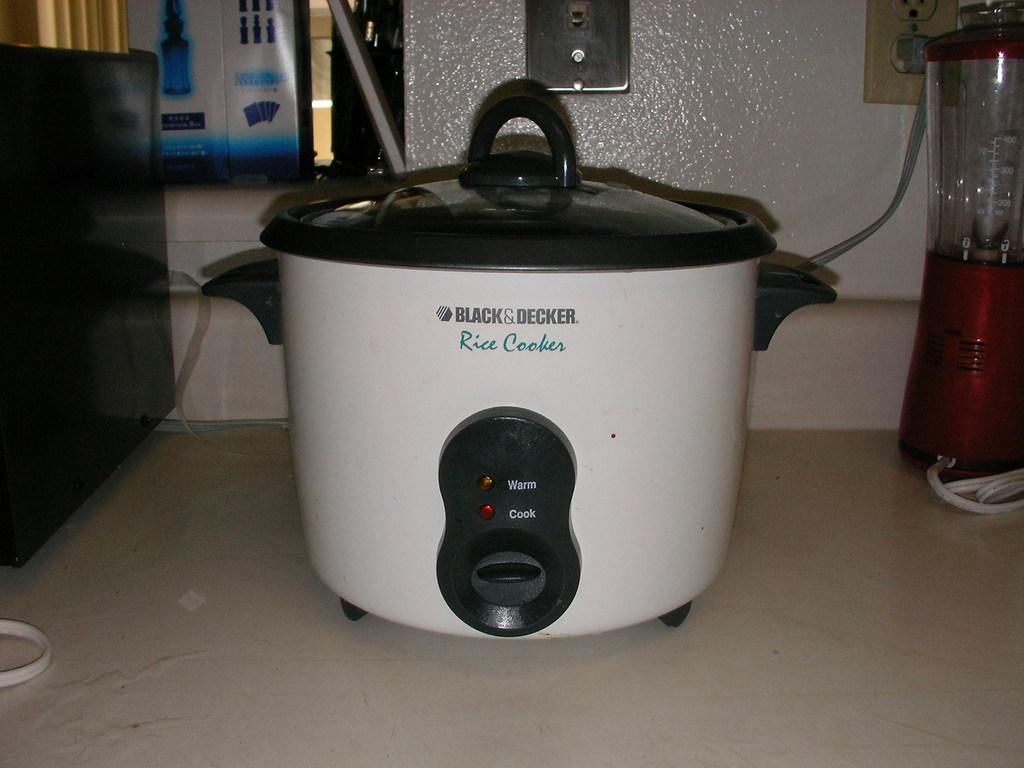What is the upper indicator light on the rice cooker for?
Make the answer very short. Warm. 